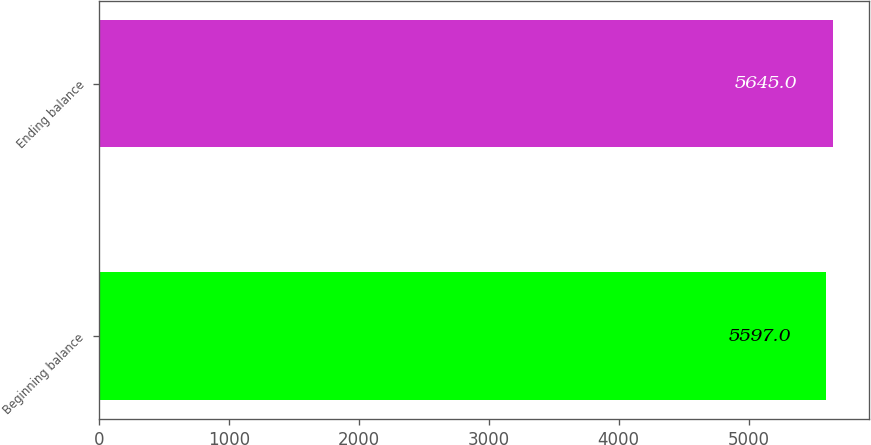Convert chart. <chart><loc_0><loc_0><loc_500><loc_500><bar_chart><fcel>Beginning balance<fcel>Ending balance<nl><fcel>5597<fcel>5645<nl></chart> 